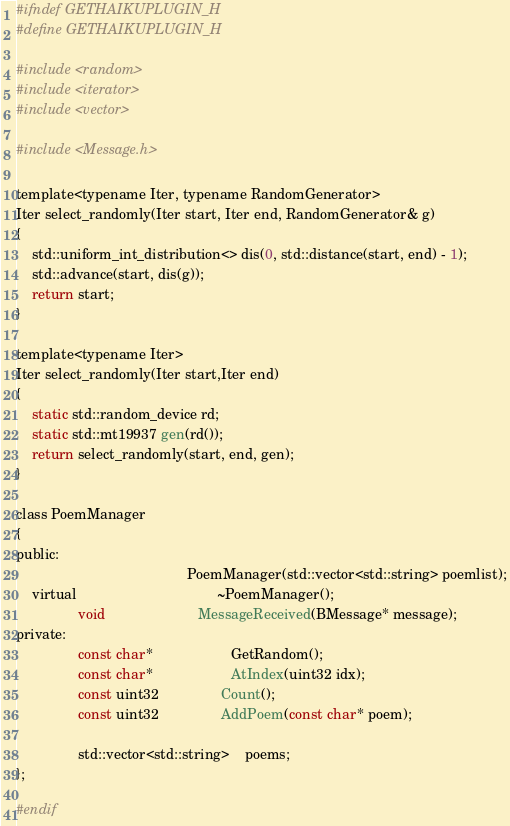<code> <loc_0><loc_0><loc_500><loc_500><_C_>#ifndef GETHAIKUPLUGIN_H
#define GETHAIKUPLUGIN_H

#include <random>
#include <iterator>
#include <vector>

#include <Message.h>

template<typename Iter, typename RandomGenerator>
Iter select_randomly(Iter start, Iter end, RandomGenerator& g)
{
	std::uniform_int_distribution<> dis(0, std::distance(start, end) - 1);
	std::advance(start, dis(g));
	return start;
}

template<typename Iter>
Iter select_randomly(Iter start,Iter end)
{
	static std::random_device rd;
	static std::mt19937 gen(rd());
	return select_randomly(start, end, gen);
}

class PoemManager
{
public:
											PoemManager(std::vector<std::string> poemlist);
	virtual									~PoemManager();
				void						MessageReceived(BMessage* message);
private:
				const char*					GetRandom();
				const char*					AtIndex(uint32 idx);
				const uint32				Count();
				const uint32				AddPoem(const char* poem);
				
				std::vector<std::string> 	poems;
};

#endif
</code> 